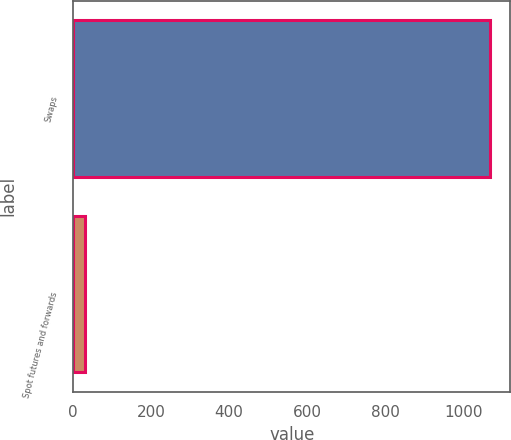Convert chart to OTSL. <chart><loc_0><loc_0><loc_500><loc_500><bar_chart><fcel>Swaps<fcel>Spot futures and forwards<nl><fcel>1067.3<fcel>31.3<nl></chart> 